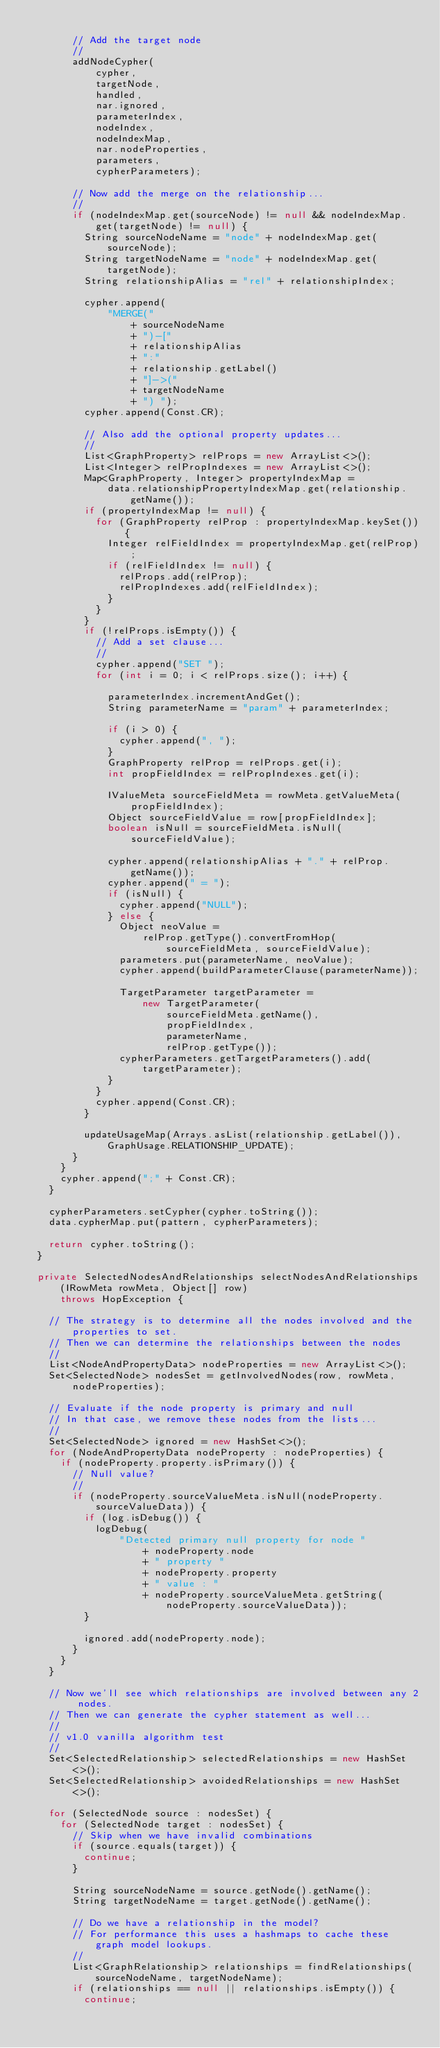<code> <loc_0><loc_0><loc_500><loc_500><_Java_>
        // Add the target node
        //
        addNodeCypher(
            cypher,
            targetNode,
            handled,
            nar.ignored,
            parameterIndex,
            nodeIndex,
            nodeIndexMap,
            nar.nodeProperties,
            parameters,
            cypherParameters);

        // Now add the merge on the relationship...
        //
        if (nodeIndexMap.get(sourceNode) != null && nodeIndexMap.get(targetNode) != null) {
          String sourceNodeName = "node" + nodeIndexMap.get(sourceNode);
          String targetNodeName = "node" + nodeIndexMap.get(targetNode);
          String relationshipAlias = "rel" + relationshipIndex;

          cypher.append(
              "MERGE("
                  + sourceNodeName
                  + ")-["
                  + relationshipAlias
                  + ":"
                  + relationship.getLabel()
                  + "]->("
                  + targetNodeName
                  + ") ");
          cypher.append(Const.CR);

          // Also add the optional property updates...
          //
          List<GraphProperty> relProps = new ArrayList<>();
          List<Integer> relPropIndexes = new ArrayList<>();
          Map<GraphProperty, Integer> propertyIndexMap =
              data.relationshipPropertyIndexMap.get(relationship.getName());
          if (propertyIndexMap != null) {
            for (GraphProperty relProp : propertyIndexMap.keySet()) {
              Integer relFieldIndex = propertyIndexMap.get(relProp);
              if (relFieldIndex != null) {
                relProps.add(relProp);
                relPropIndexes.add(relFieldIndex);
              }
            }
          }
          if (!relProps.isEmpty()) {
            // Add a set clause...
            //
            cypher.append("SET ");
            for (int i = 0; i < relProps.size(); i++) {

              parameterIndex.incrementAndGet();
              String parameterName = "param" + parameterIndex;

              if (i > 0) {
                cypher.append(", ");
              }
              GraphProperty relProp = relProps.get(i);
              int propFieldIndex = relPropIndexes.get(i);

              IValueMeta sourceFieldMeta = rowMeta.getValueMeta(propFieldIndex);
              Object sourceFieldValue = row[propFieldIndex];
              boolean isNull = sourceFieldMeta.isNull(sourceFieldValue);

              cypher.append(relationshipAlias + "." + relProp.getName());
              cypher.append(" = ");
              if (isNull) {
                cypher.append("NULL");
              } else {
                Object neoValue =
                    relProp.getType().convertFromHop(sourceFieldMeta, sourceFieldValue);
                parameters.put(parameterName, neoValue);
                cypher.append(buildParameterClause(parameterName));

                TargetParameter targetParameter =
                    new TargetParameter(
                        sourceFieldMeta.getName(),
                        propFieldIndex,
                        parameterName,
                        relProp.getType());
                cypherParameters.getTargetParameters().add(targetParameter);
              }
            }
            cypher.append(Const.CR);
          }

          updateUsageMap(Arrays.asList(relationship.getLabel()), GraphUsage.RELATIONSHIP_UPDATE);
        }
      }
      cypher.append(";" + Const.CR);
    }

    cypherParameters.setCypher(cypher.toString());
    data.cypherMap.put(pattern, cypherParameters);

    return cypher.toString();
  }

  private SelectedNodesAndRelationships selectNodesAndRelationships(IRowMeta rowMeta, Object[] row)
      throws HopException {

    // The strategy is to determine all the nodes involved and the properties to set.
    // Then we can determine the relationships between the nodes
    //
    List<NodeAndPropertyData> nodeProperties = new ArrayList<>();
    Set<SelectedNode> nodesSet = getInvolvedNodes(row, rowMeta, nodeProperties);

    // Evaluate if the node property is primary and null
    // In that case, we remove these nodes from the lists...
    //
    Set<SelectedNode> ignored = new HashSet<>();
    for (NodeAndPropertyData nodeProperty : nodeProperties) {
      if (nodeProperty.property.isPrimary()) {
        // Null value?
        //
        if (nodeProperty.sourceValueMeta.isNull(nodeProperty.sourceValueData)) {
          if (log.isDebug()) {
            logDebug(
                "Detected primary null property for node "
                    + nodeProperty.node
                    + " property "
                    + nodeProperty.property
                    + " value : "
                    + nodeProperty.sourceValueMeta.getString(nodeProperty.sourceValueData));
          }

          ignored.add(nodeProperty.node);
        }
      }
    }

    // Now we'll see which relationships are involved between any 2 nodes.
    // Then we can generate the cypher statement as well...
    //
    // v1.0 vanilla algorithm test
    //
    Set<SelectedRelationship> selectedRelationships = new HashSet<>();
    Set<SelectedRelationship> avoidedRelationships = new HashSet<>();

    for (SelectedNode source : nodesSet) {
      for (SelectedNode target : nodesSet) {
        // Skip when we have invalid combinations
        if (source.equals(target)) {
          continue;
        }

        String sourceNodeName = source.getNode().getName();
        String targetNodeName = target.getNode().getName();

        // Do we have a relationship in the model?
        // For performance this uses a hashmaps to cache these graph model lookups.
        //
        List<GraphRelationship> relationships = findRelationships(sourceNodeName, targetNodeName);
        if (relationships == null || relationships.isEmpty()) {
          continue;</code> 